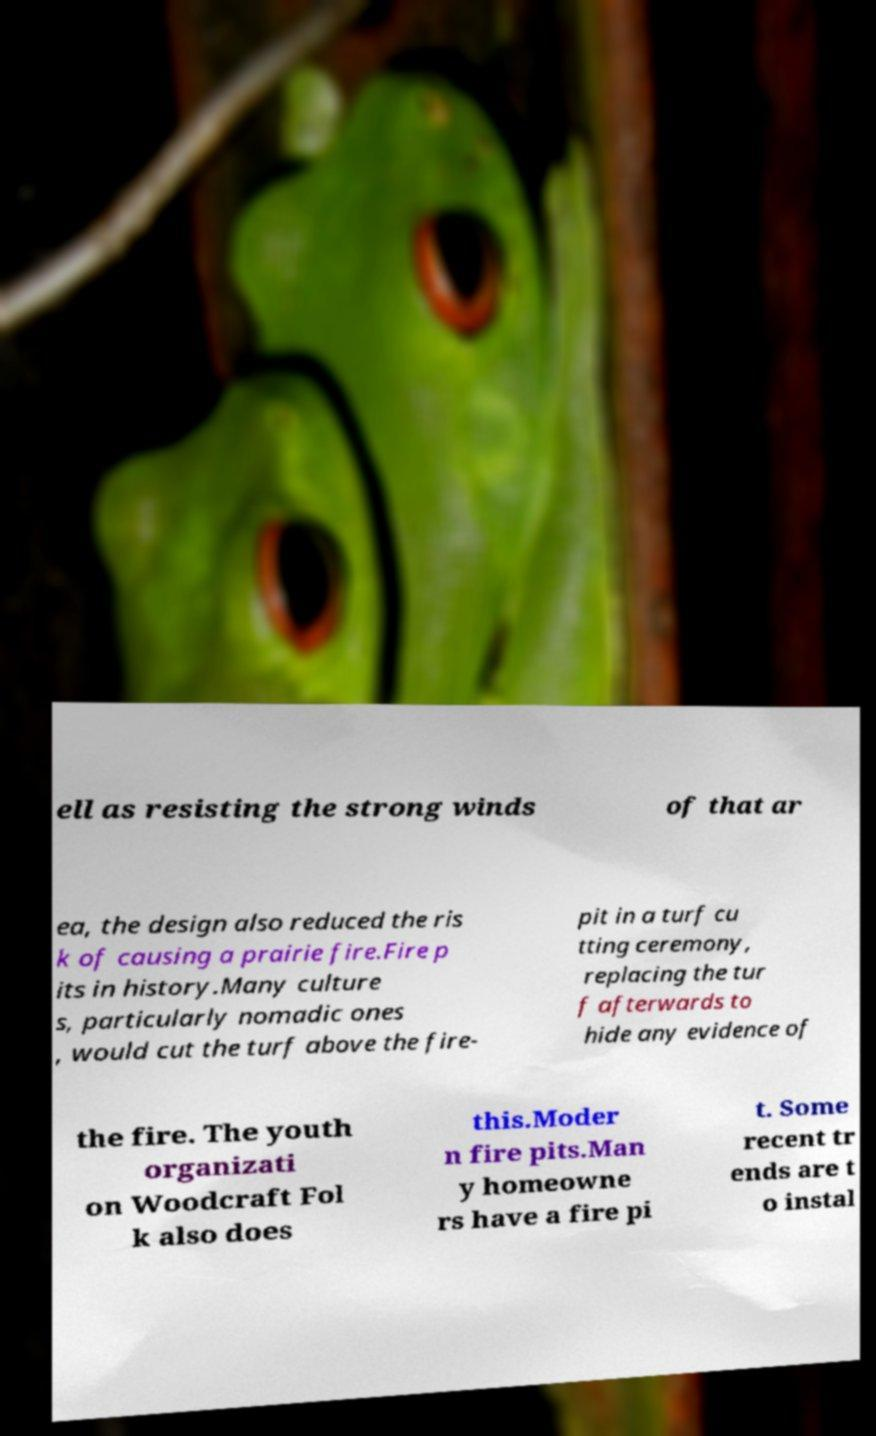Please read and relay the text visible in this image. What does it say? ell as resisting the strong winds of that ar ea, the design also reduced the ris k of causing a prairie fire.Fire p its in history.Many culture s, particularly nomadic ones , would cut the turf above the fire- pit in a turf cu tting ceremony, replacing the tur f afterwards to hide any evidence of the fire. The youth organizati on Woodcraft Fol k also does this.Moder n fire pits.Man y homeowne rs have a fire pi t. Some recent tr ends are t o instal 